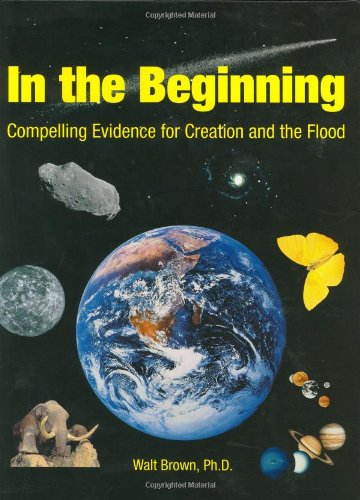Who wrote this book? The book 'In the Beginning: Compelling Evidence for Creation and the Flood' was authored by Walter T. Brown, a Ph.D. holder, who explores themes related to creationism and the biblical flood. 